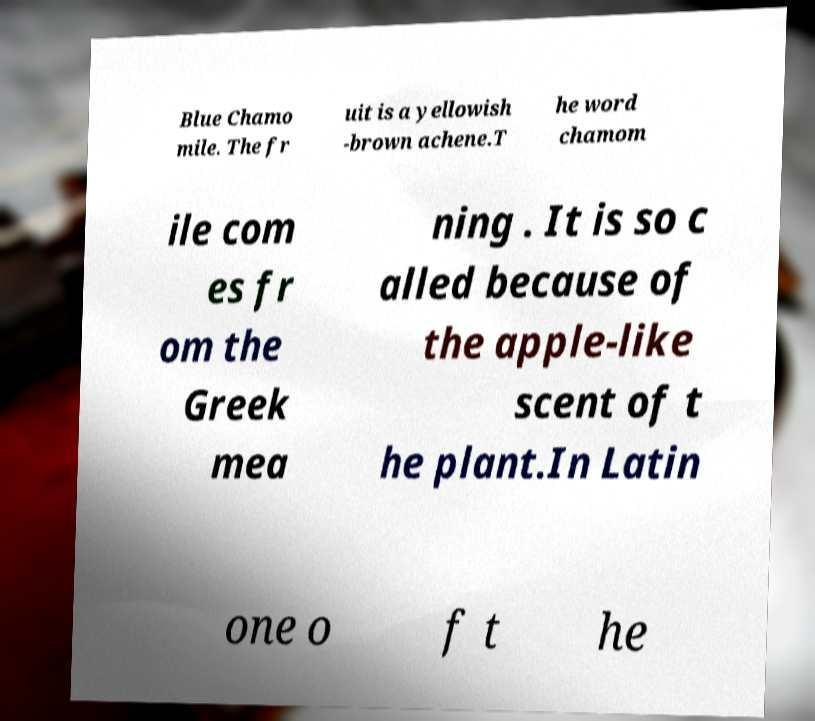I need the written content from this picture converted into text. Can you do that? Blue Chamo mile. The fr uit is a yellowish -brown achene.T he word chamom ile com es fr om the Greek mea ning . It is so c alled because of the apple-like scent of t he plant.In Latin one o f t he 